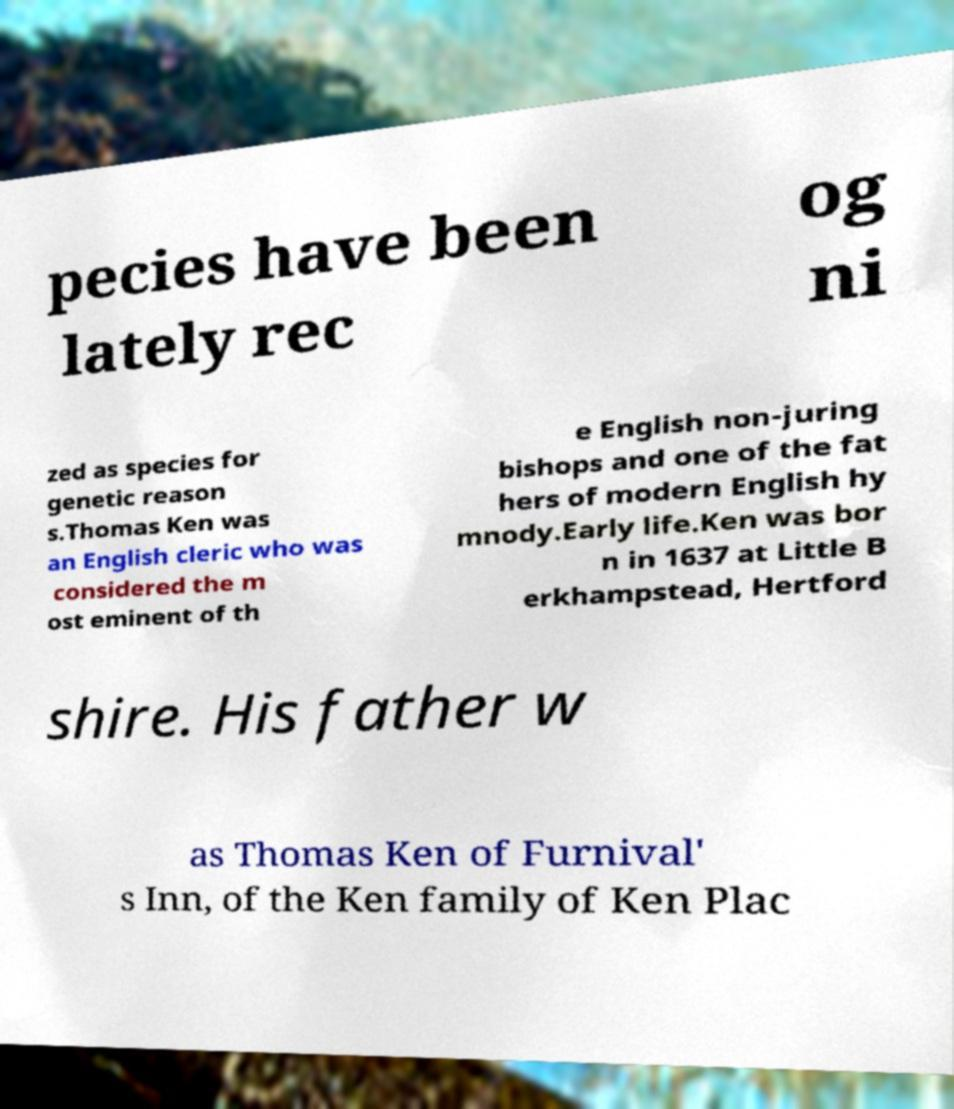Please identify and transcribe the text found in this image. pecies have been lately rec og ni zed as species for genetic reason s.Thomas Ken was an English cleric who was considered the m ost eminent of th e English non-juring bishops and one of the fat hers of modern English hy mnody.Early life.Ken was bor n in 1637 at Little B erkhampstead, Hertford shire. His father w as Thomas Ken of Furnival' s Inn, of the Ken family of Ken Plac 